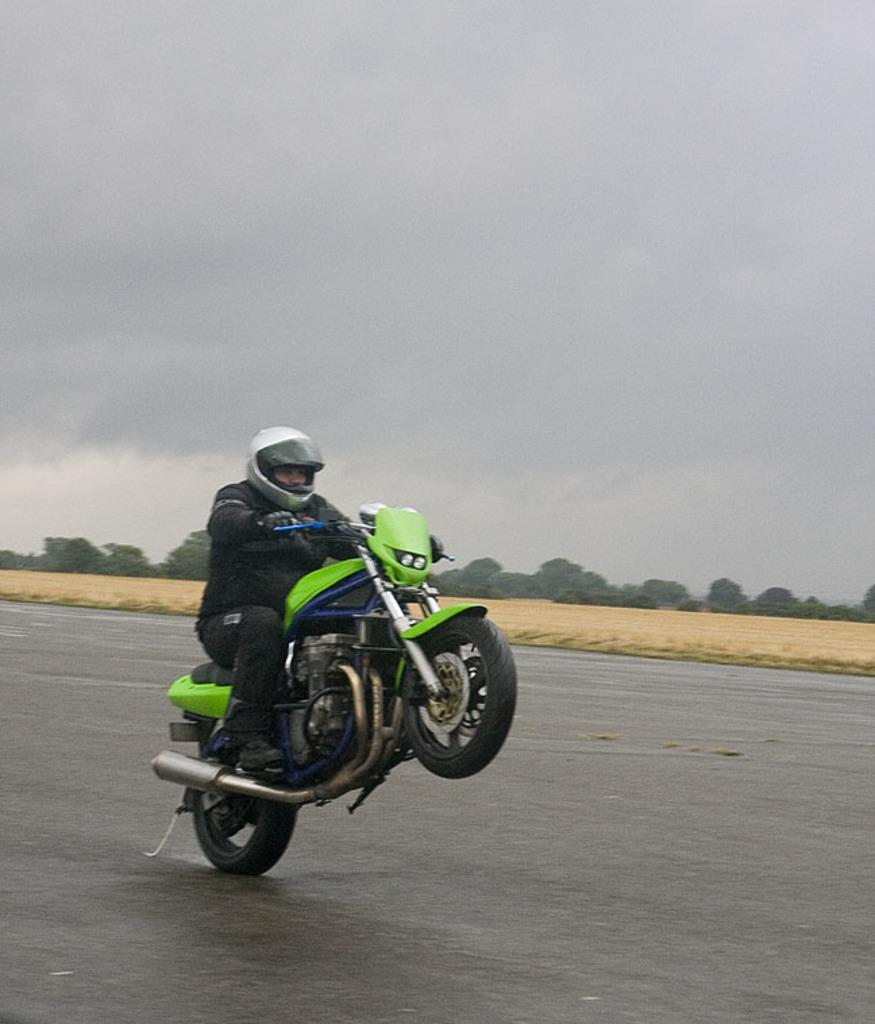What is happening in the foreground of the image? There is a man on a bike in the foreground of the image. How is the bike being used in the image? The bike is moving on one tire in the image. What can be seen in the background of the image? There are trees and the sky visible in the background of the image. What is the condition of the sky in the image? The sky has clouds in the image. What color is the man's shirt in the image? There is no information about the man's shirt in the provided facts, so we cannot determine its color. What is the chance of rain in the image? The provided facts do not mention any weather conditions, so we cannot determine the chance of rain. 